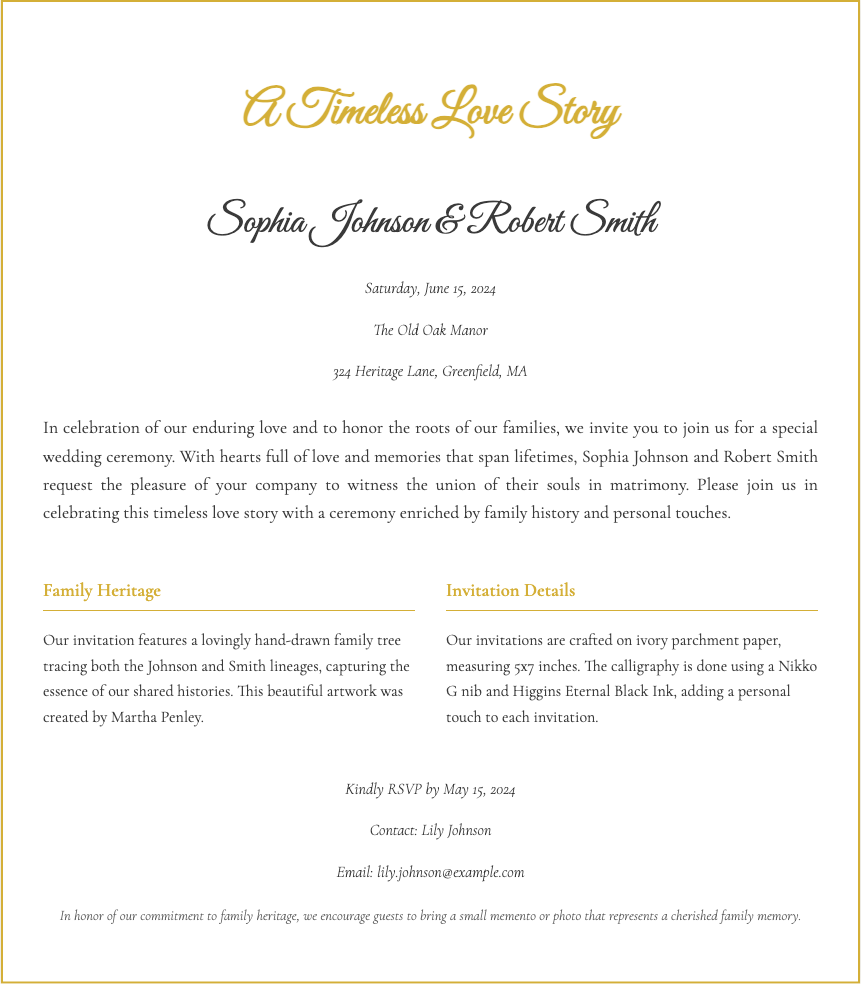What are the names of the couple? The names of the couple are mentioned prominently in the invitation as they are the central figures being celebrated.
Answer: Sophia Johnson & Robert Smith What is the date of the wedding? The date is specified in the invitation section, indicating when the celebration will take place.
Answer: Saturday, June 15, 2024 Where is the wedding venue located? The location is provided in the venue details, giving the exact place for the ceremony.
Answer: The Old Oak Manor, 324 Heritage Lane, Greenfield, MA Who created the family tree artwork? The document mentions the artist who lovingly crafted the family tree, highlighting the personal touch.
Answer: Martha Penley What type of paper is used for the invitations? The invitation details section describes the physical characteristics of the paper used, emphasizing its traditional style.
Answer: Ivory parchment paper What is the RSVP deadline? The RSVP information specifies the date by which guests should confirm their attendance.
Answer: May 15, 2024 What type of ink is used for the calligraphy? The invitation detail section specifies the type of ink, underscoring the elegance of the invitations.
Answer: Higgins Eternal Black Ink What is encouraged to bring by guests? The additional notes section suggests what guests should bring, adding a personal touch to the celebration.
Answer: A small memento or photo 